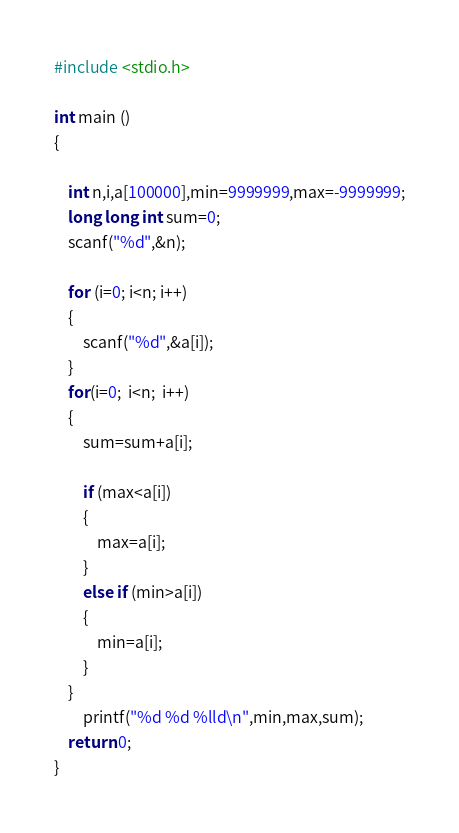Convert code to text. <code><loc_0><loc_0><loc_500><loc_500><_C_>#include <stdio.h>
 
int main ()
{
 
    int n,i,a[100000],min=9999999,max=-9999999;
    long long int sum=0;
    scanf("%d",&n);
 
    for (i=0; i<n; i++)
    {
        scanf("%d",&a[i]);
    }
    for(i=0;  i<n;  i++)
    {
        sum=sum+a[i];
         
        if (max<a[i])
        {
            max=a[i];
        }
        else if (min>a[i])
        {
            min=a[i];
        }
    }
        printf("%d %d %lld\n",min,max,sum);
    return 0;
}</code> 